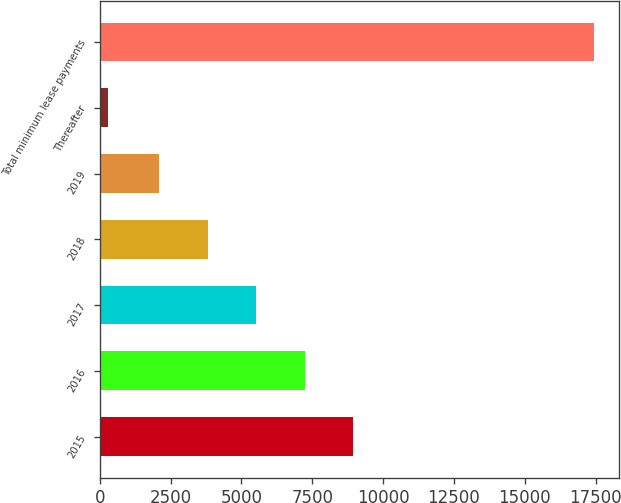<chart> <loc_0><loc_0><loc_500><loc_500><bar_chart><fcel>2015<fcel>2016<fcel>2017<fcel>2018<fcel>2019<fcel>Thereafter<fcel>Total minimum lease payments<nl><fcel>8958<fcel>7241.5<fcel>5525<fcel>3808.5<fcel>2092<fcel>280<fcel>17445<nl></chart> 